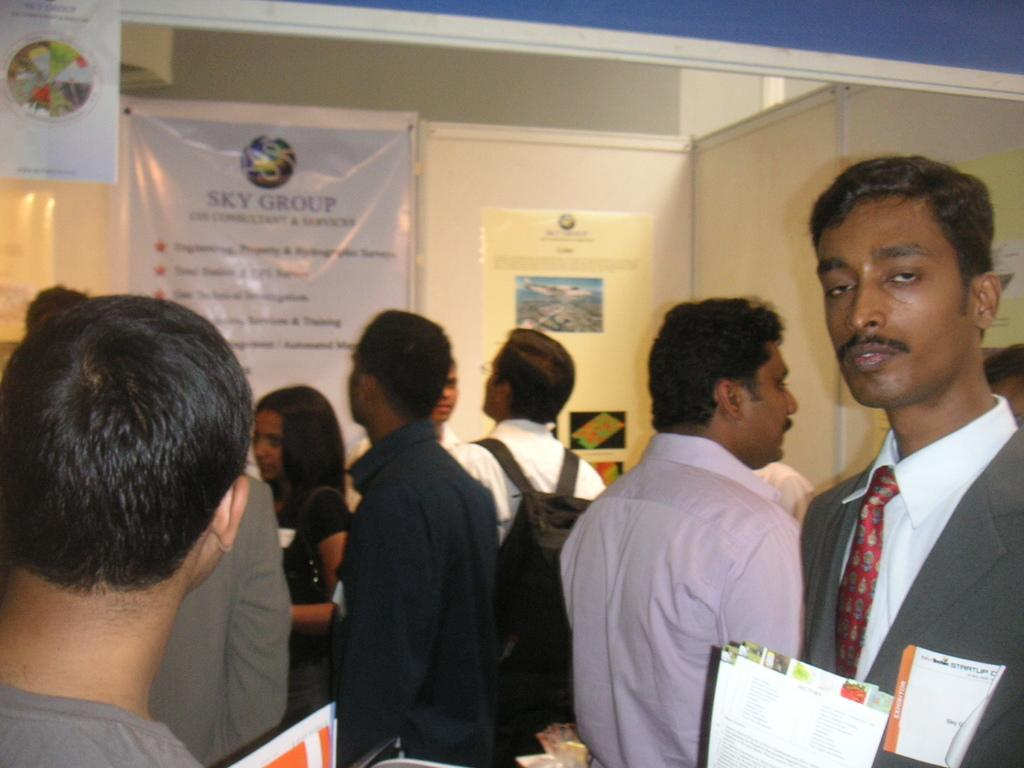Who or what can be seen in the image? There are people in the image. What objects are visible in the image? Papers are visible in the image. What can be seen in the background of the image? There are banners and a wall in the background of the image. What type of substance is the turkey cooking in the image? There is no turkey or cooking activity present in the image. 